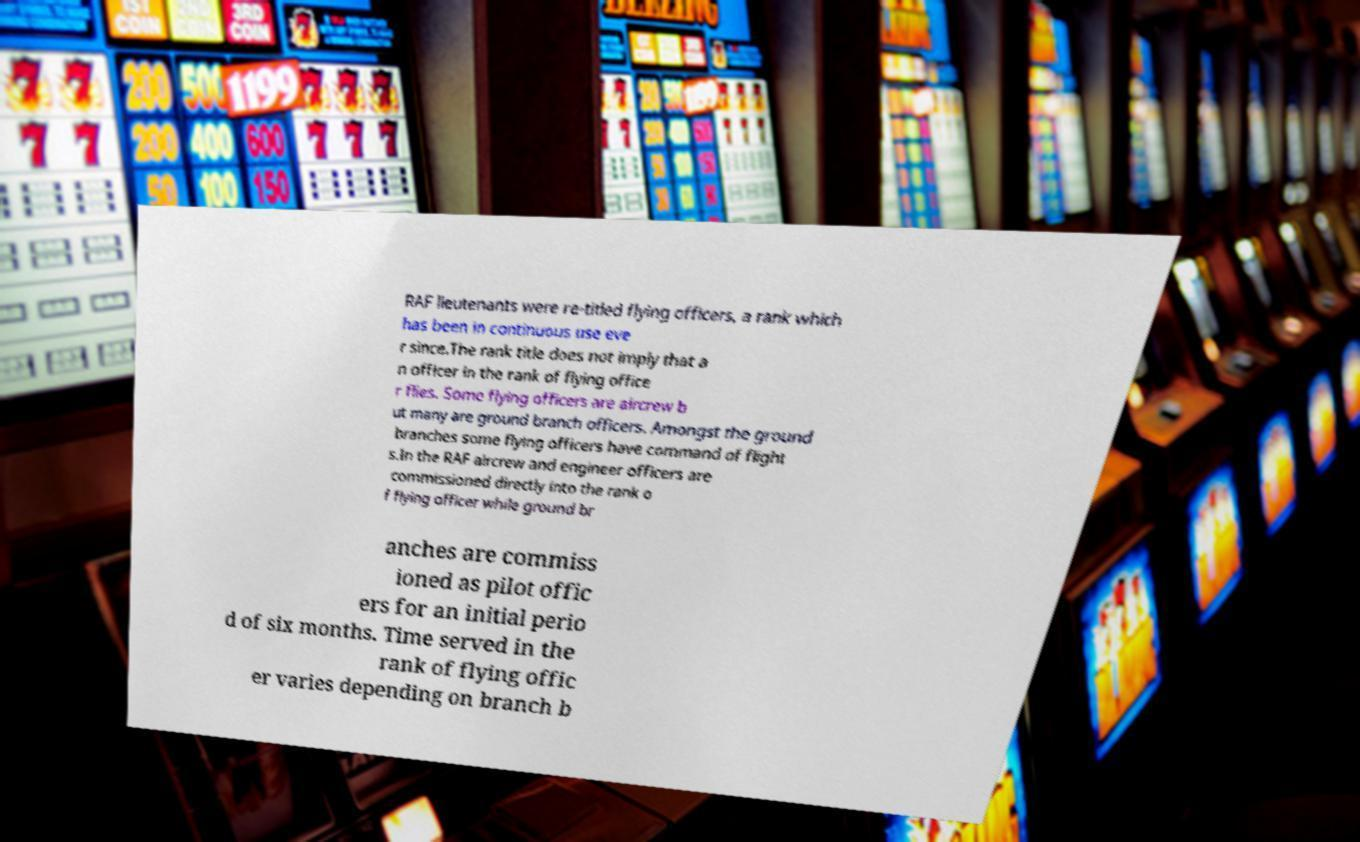What messages or text are displayed in this image? I need them in a readable, typed format. RAF lieutenants were re-titled flying officers, a rank which has been in continuous use eve r since.The rank title does not imply that a n officer in the rank of flying office r flies. Some flying officers are aircrew b ut many are ground branch officers. Amongst the ground branches some flying officers have command of flight s.In the RAF aircrew and engineer officers are commissioned directly into the rank o f flying officer while ground br anches are commiss ioned as pilot offic ers for an initial perio d of six months. Time served in the rank of flying offic er varies depending on branch b 